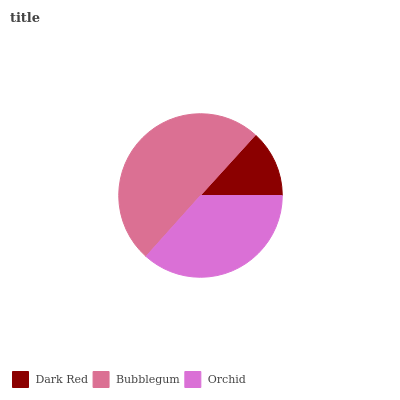Is Dark Red the minimum?
Answer yes or no. Yes. Is Bubblegum the maximum?
Answer yes or no. Yes. Is Orchid the minimum?
Answer yes or no. No. Is Orchid the maximum?
Answer yes or no. No. Is Bubblegum greater than Orchid?
Answer yes or no. Yes. Is Orchid less than Bubblegum?
Answer yes or no. Yes. Is Orchid greater than Bubblegum?
Answer yes or no. No. Is Bubblegum less than Orchid?
Answer yes or no. No. Is Orchid the high median?
Answer yes or no. Yes. Is Orchid the low median?
Answer yes or no. Yes. Is Dark Red the high median?
Answer yes or no. No. Is Dark Red the low median?
Answer yes or no. No. 